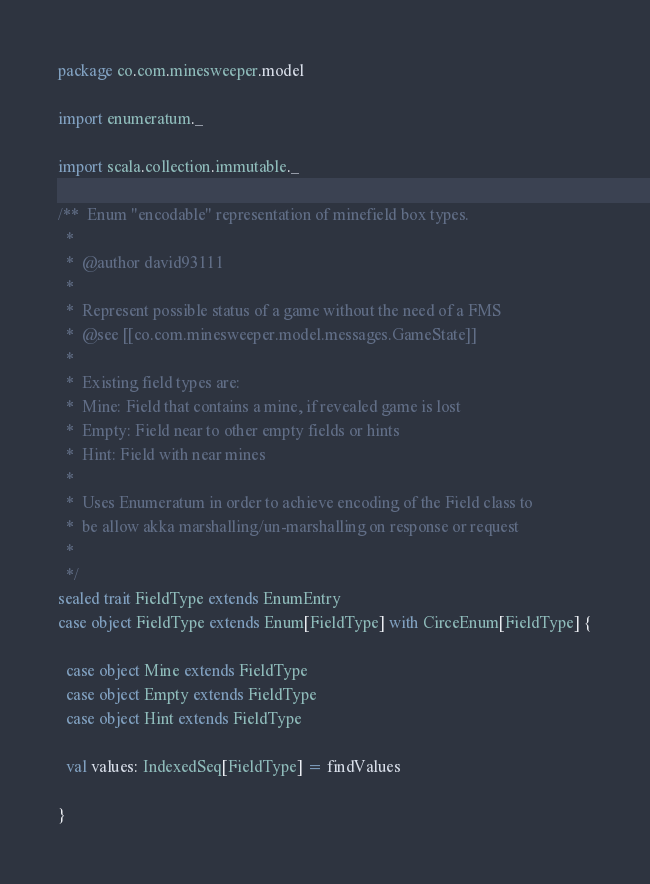<code> <loc_0><loc_0><loc_500><loc_500><_Scala_>package co.com.minesweeper.model

import enumeratum._

import scala.collection.immutable._

/**  Enum "encodable" representation of minefield box types.
  *
  *  @author david93111
  *
  *  Represent possible status of a game without the need of a FMS
  *  @see [[co.com.minesweeper.model.messages.GameState]]
  *
  *  Existing field types are:
  *  Mine: Field that contains a mine, if revealed game is lost
  *  Empty: Field near to other empty fields or hints
  *  Hint: Field with near mines
  *
  *  Uses Enumeratum in order to achieve encoding of the Field class to
  *  be allow akka marshalling/un-marshalling on response or request
  *
  */
sealed trait FieldType extends EnumEntry
case object FieldType extends Enum[FieldType] with CirceEnum[FieldType] {

  case object Mine extends FieldType
  case object Empty extends FieldType
  case object Hint extends FieldType

  val values: IndexedSeq[FieldType] = findValues

}
</code> 